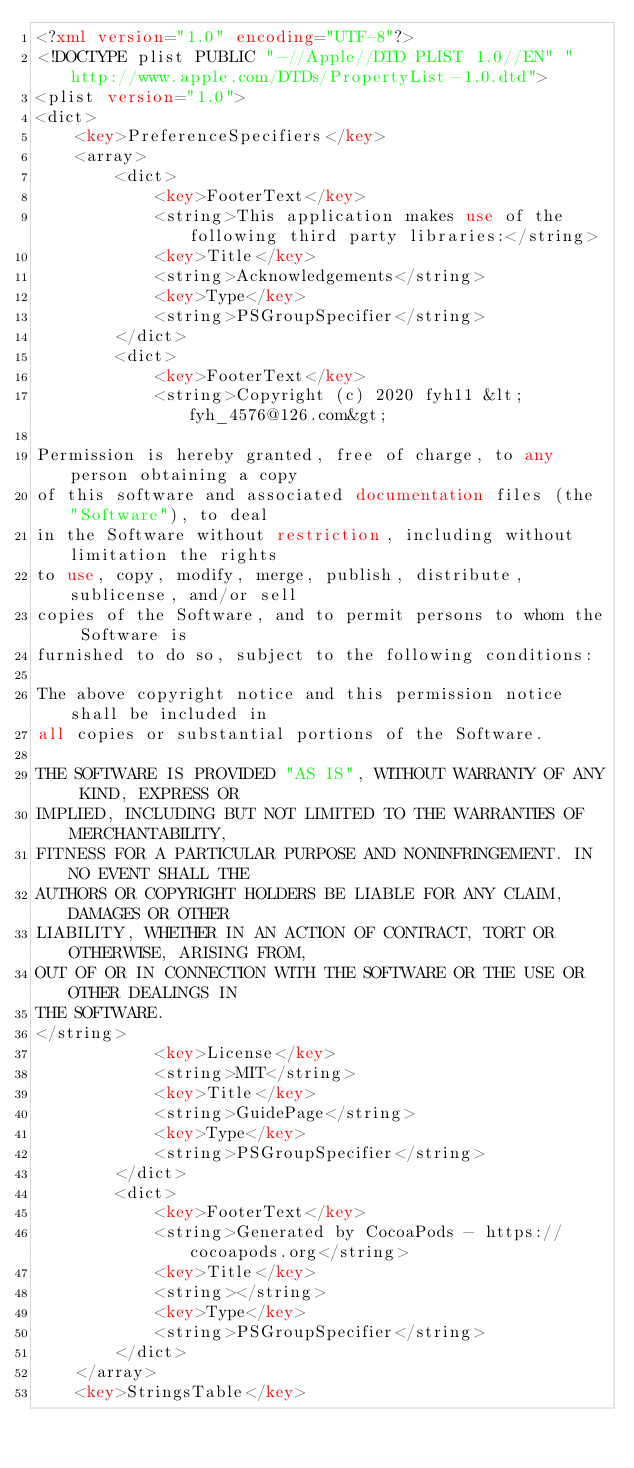Convert code to text. <code><loc_0><loc_0><loc_500><loc_500><_XML_><?xml version="1.0" encoding="UTF-8"?>
<!DOCTYPE plist PUBLIC "-//Apple//DTD PLIST 1.0//EN" "http://www.apple.com/DTDs/PropertyList-1.0.dtd">
<plist version="1.0">
<dict>
	<key>PreferenceSpecifiers</key>
	<array>
		<dict>
			<key>FooterText</key>
			<string>This application makes use of the following third party libraries:</string>
			<key>Title</key>
			<string>Acknowledgements</string>
			<key>Type</key>
			<string>PSGroupSpecifier</string>
		</dict>
		<dict>
			<key>FooterText</key>
			<string>Copyright (c) 2020 fyh11 &lt;fyh_4576@126.com&gt;

Permission is hereby granted, free of charge, to any person obtaining a copy
of this software and associated documentation files (the "Software"), to deal
in the Software without restriction, including without limitation the rights
to use, copy, modify, merge, publish, distribute, sublicense, and/or sell
copies of the Software, and to permit persons to whom the Software is
furnished to do so, subject to the following conditions:

The above copyright notice and this permission notice shall be included in
all copies or substantial portions of the Software.

THE SOFTWARE IS PROVIDED "AS IS", WITHOUT WARRANTY OF ANY KIND, EXPRESS OR
IMPLIED, INCLUDING BUT NOT LIMITED TO THE WARRANTIES OF MERCHANTABILITY,
FITNESS FOR A PARTICULAR PURPOSE AND NONINFRINGEMENT. IN NO EVENT SHALL THE
AUTHORS OR COPYRIGHT HOLDERS BE LIABLE FOR ANY CLAIM, DAMAGES OR OTHER
LIABILITY, WHETHER IN AN ACTION OF CONTRACT, TORT OR OTHERWISE, ARISING FROM,
OUT OF OR IN CONNECTION WITH THE SOFTWARE OR THE USE OR OTHER DEALINGS IN
THE SOFTWARE.
</string>
			<key>License</key>
			<string>MIT</string>
			<key>Title</key>
			<string>GuidePage</string>
			<key>Type</key>
			<string>PSGroupSpecifier</string>
		</dict>
		<dict>
			<key>FooterText</key>
			<string>Generated by CocoaPods - https://cocoapods.org</string>
			<key>Title</key>
			<string></string>
			<key>Type</key>
			<string>PSGroupSpecifier</string>
		</dict>
	</array>
	<key>StringsTable</key></code> 